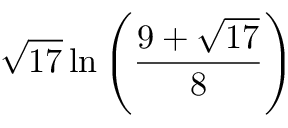Convert formula to latex. <formula><loc_0><loc_0><loc_500><loc_500>{ \sqrt { 1 7 } } \ln \left ( { \frac { 9 + { \sqrt { 1 7 } } } { 8 } } \right )</formula> 